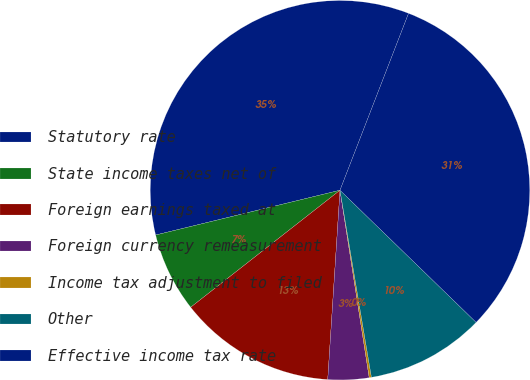Convert chart to OTSL. <chart><loc_0><loc_0><loc_500><loc_500><pie_chart><fcel>Statutory rate<fcel>State income taxes net of<fcel>Foreign earnings taxed at<fcel>Foreign currency remeasurement<fcel>Income tax adjustment to filed<fcel>Other<fcel>Effective income tax rate<nl><fcel>34.68%<fcel>6.79%<fcel>13.39%<fcel>3.49%<fcel>0.19%<fcel>10.09%<fcel>31.38%<nl></chart> 